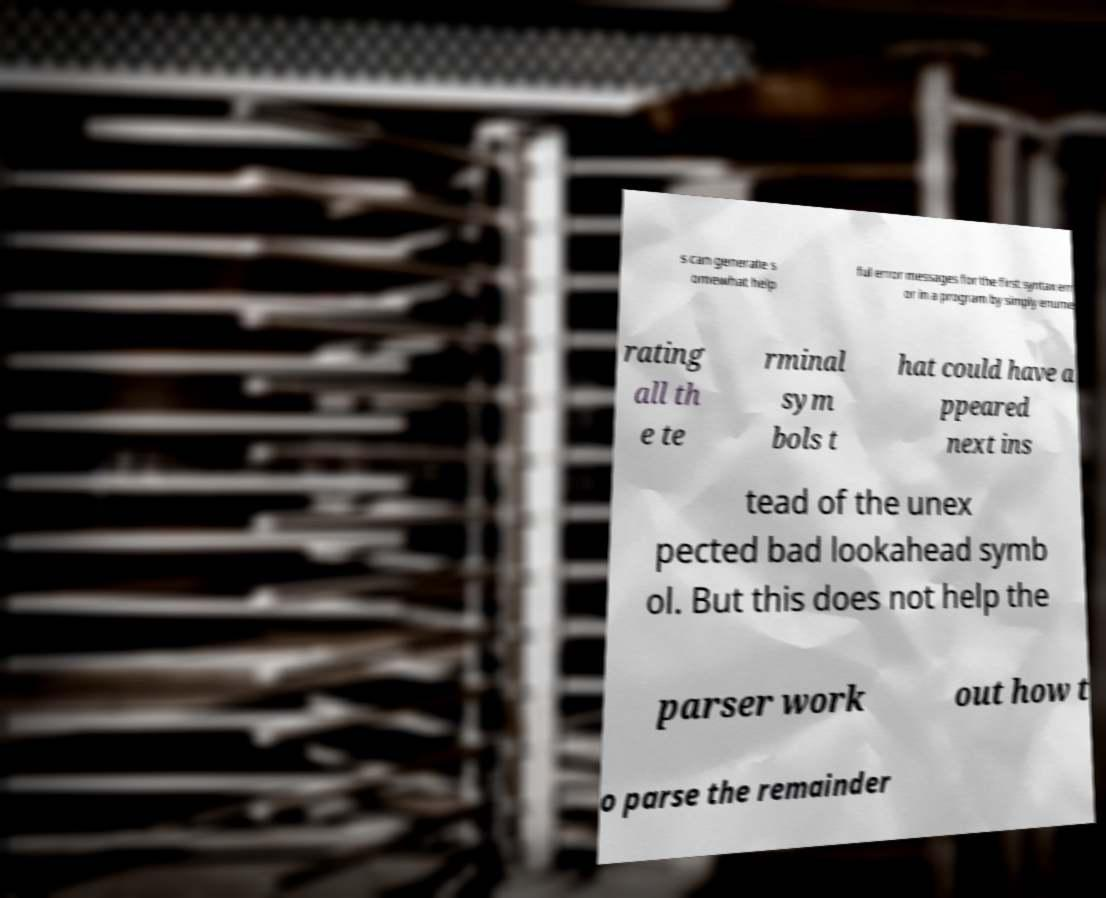Please identify and transcribe the text found in this image. s can generate s omewhat help ful error messages for the first syntax err or in a program by simply enume rating all th e te rminal sym bols t hat could have a ppeared next ins tead of the unex pected bad lookahead symb ol. But this does not help the parser work out how t o parse the remainder 